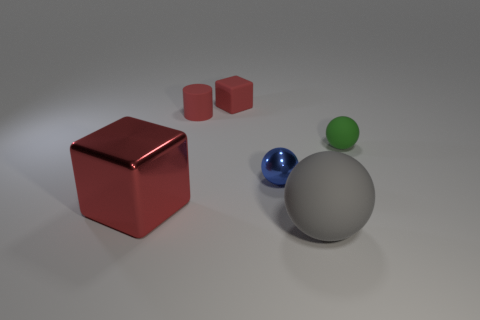Add 1 large red objects. How many objects exist? 7 Subtract all cylinders. How many objects are left? 5 Add 1 tiny blue things. How many tiny blue things exist? 2 Subtract 0 yellow spheres. How many objects are left? 6 Subtract all blue metallic balls. Subtract all tiny red rubber things. How many objects are left? 3 Add 6 big matte balls. How many big matte balls are left? 7 